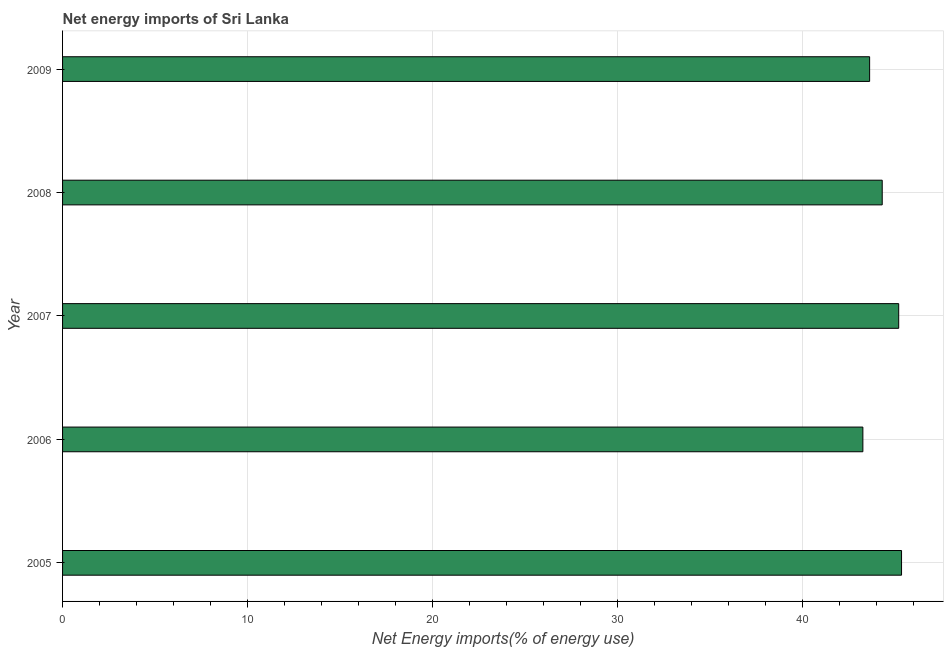Does the graph contain any zero values?
Provide a succinct answer. No. Does the graph contain grids?
Give a very brief answer. Yes. What is the title of the graph?
Your answer should be compact. Net energy imports of Sri Lanka. What is the label or title of the X-axis?
Your answer should be compact. Net Energy imports(% of energy use). What is the energy imports in 2006?
Your response must be concise. 43.25. Across all years, what is the maximum energy imports?
Make the answer very short. 45.33. Across all years, what is the minimum energy imports?
Give a very brief answer. 43.25. In which year was the energy imports minimum?
Your response must be concise. 2006. What is the sum of the energy imports?
Make the answer very short. 221.66. What is the difference between the energy imports in 2005 and 2007?
Your answer should be compact. 0.15. What is the average energy imports per year?
Offer a terse response. 44.33. What is the median energy imports?
Your answer should be very brief. 44.29. Do a majority of the years between 2008 and 2007 (inclusive) have energy imports greater than 42 %?
Give a very brief answer. No. Is the energy imports in 2006 less than that in 2007?
Keep it short and to the point. Yes. What is the difference between the highest and the second highest energy imports?
Provide a succinct answer. 0.15. Is the sum of the energy imports in 2006 and 2008 greater than the maximum energy imports across all years?
Your response must be concise. Yes. What is the difference between the highest and the lowest energy imports?
Ensure brevity in your answer.  2.09. Are all the bars in the graph horizontal?
Make the answer very short. Yes. What is the difference between two consecutive major ticks on the X-axis?
Keep it short and to the point. 10. What is the Net Energy imports(% of energy use) in 2005?
Make the answer very short. 45.33. What is the Net Energy imports(% of energy use) in 2006?
Make the answer very short. 43.25. What is the Net Energy imports(% of energy use) of 2007?
Ensure brevity in your answer.  45.18. What is the Net Energy imports(% of energy use) of 2008?
Your answer should be very brief. 44.29. What is the Net Energy imports(% of energy use) in 2009?
Keep it short and to the point. 43.61. What is the difference between the Net Energy imports(% of energy use) in 2005 and 2006?
Provide a succinct answer. 2.09. What is the difference between the Net Energy imports(% of energy use) in 2005 and 2007?
Make the answer very short. 0.15. What is the difference between the Net Energy imports(% of energy use) in 2005 and 2008?
Keep it short and to the point. 1.04. What is the difference between the Net Energy imports(% of energy use) in 2005 and 2009?
Your answer should be very brief. 1.72. What is the difference between the Net Energy imports(% of energy use) in 2006 and 2007?
Your response must be concise. -1.94. What is the difference between the Net Energy imports(% of energy use) in 2006 and 2008?
Provide a short and direct response. -1.05. What is the difference between the Net Energy imports(% of energy use) in 2006 and 2009?
Your response must be concise. -0.36. What is the difference between the Net Energy imports(% of energy use) in 2007 and 2008?
Keep it short and to the point. 0.89. What is the difference between the Net Energy imports(% of energy use) in 2007 and 2009?
Keep it short and to the point. 1.57. What is the difference between the Net Energy imports(% of energy use) in 2008 and 2009?
Make the answer very short. 0.68. What is the ratio of the Net Energy imports(% of energy use) in 2005 to that in 2006?
Give a very brief answer. 1.05. What is the ratio of the Net Energy imports(% of energy use) in 2006 to that in 2008?
Your response must be concise. 0.98. What is the ratio of the Net Energy imports(% of energy use) in 2007 to that in 2008?
Your answer should be compact. 1.02. What is the ratio of the Net Energy imports(% of energy use) in 2007 to that in 2009?
Your response must be concise. 1.04. What is the ratio of the Net Energy imports(% of energy use) in 2008 to that in 2009?
Keep it short and to the point. 1.02. 